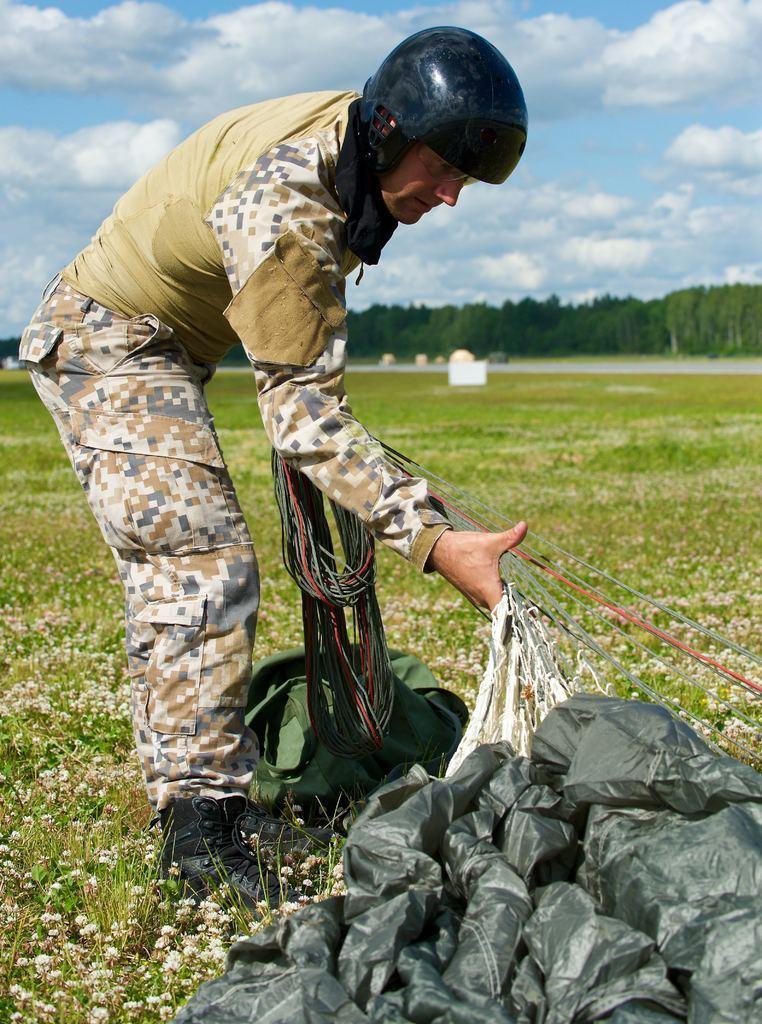In one or two sentences, can you explain what this image depicts? In the center of the image there is a person standing on the grass holding a ropes. At the bottom of the image we can see cover. In the background we can see plants, flowers, road, trees, sky and clouds. 